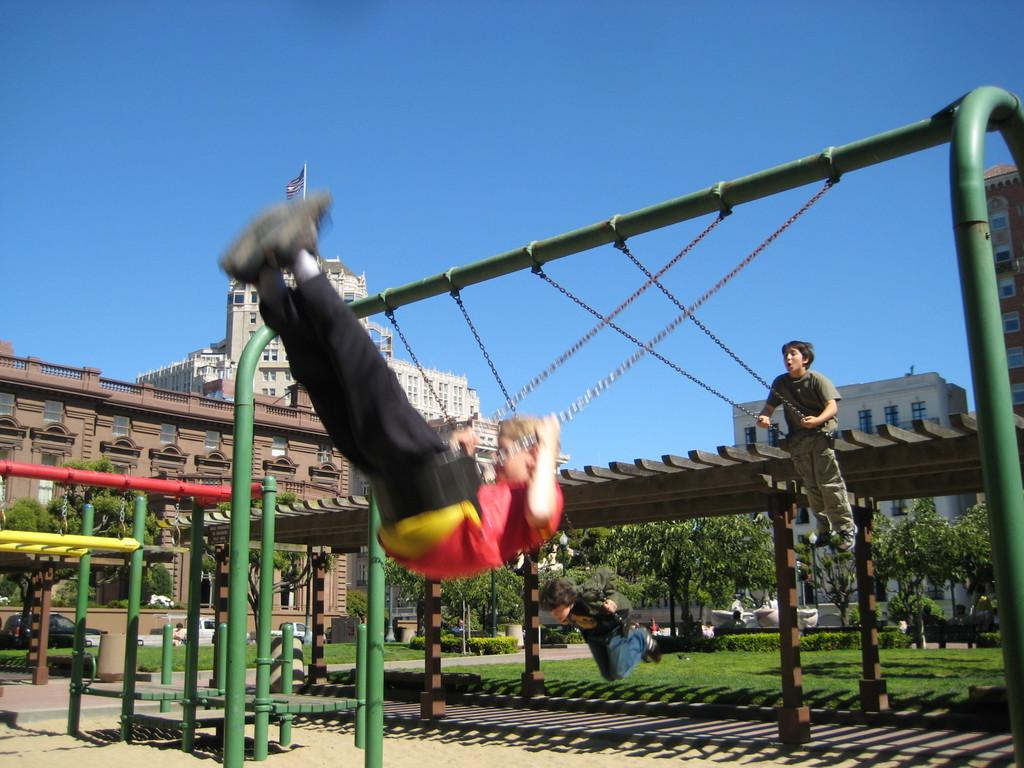What type of location is shown in the image? The image depicts a park. What activity are the children engaged in at the park? Children are swinging on a cradle in the park. What can be seen in the background of the image? There are huge buildings behind the park. What natural elements are present in the park? Many trees are present around the park. What type of wood is used to make the grandmother's rocking chair in the image? There is no grandmother or rocking chair present in the image. 